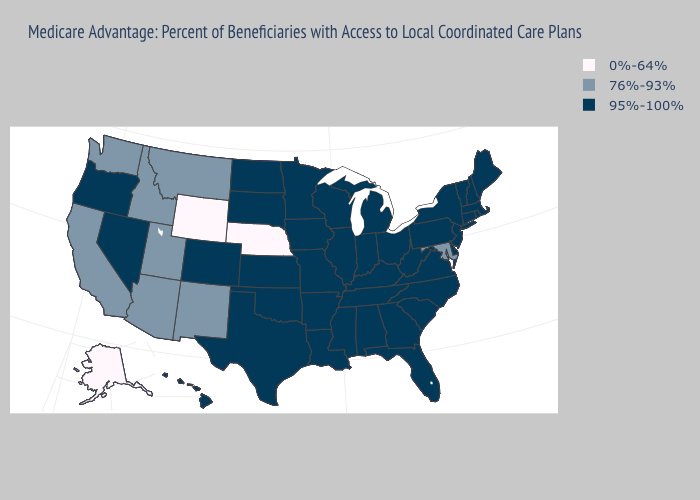Name the states that have a value in the range 0%-64%?
Give a very brief answer. Nebraska, Alaska, Wyoming. Does New Jersey have a higher value than Nebraska?
Give a very brief answer. Yes. What is the value of South Carolina?
Short answer required. 95%-100%. What is the value of Michigan?
Give a very brief answer. 95%-100%. Name the states that have a value in the range 95%-100%?
Concise answer only. Colorado, Connecticut, Delaware, Florida, Georgia, Hawaii, Iowa, Illinois, Indiana, Kansas, Kentucky, Louisiana, Massachusetts, Maine, Michigan, Minnesota, Missouri, Mississippi, North Carolina, North Dakota, New Hampshire, New Jersey, Nevada, New York, Ohio, Oklahoma, Oregon, Pennsylvania, Rhode Island, South Carolina, South Dakota, Tennessee, Texas, Virginia, Vermont, Wisconsin, West Virginia, Alabama, Arkansas. Among the states that border Vermont , which have the lowest value?
Write a very short answer. Massachusetts, New Hampshire, New York. Does Alaska have the highest value in the USA?
Short answer required. No. Which states have the lowest value in the South?
Keep it brief. Maryland. What is the value of Indiana?
Quick response, please. 95%-100%. Name the states that have a value in the range 76%-93%?
Give a very brief answer. California, Idaho, Maryland, Montana, New Mexico, Utah, Washington, Arizona. Name the states that have a value in the range 76%-93%?
Give a very brief answer. California, Idaho, Maryland, Montana, New Mexico, Utah, Washington, Arizona. Name the states that have a value in the range 76%-93%?
Short answer required. California, Idaho, Maryland, Montana, New Mexico, Utah, Washington, Arizona. Does Washington have a higher value than Nebraska?
Answer briefly. Yes. Which states have the lowest value in the USA?
Concise answer only. Nebraska, Alaska, Wyoming. 